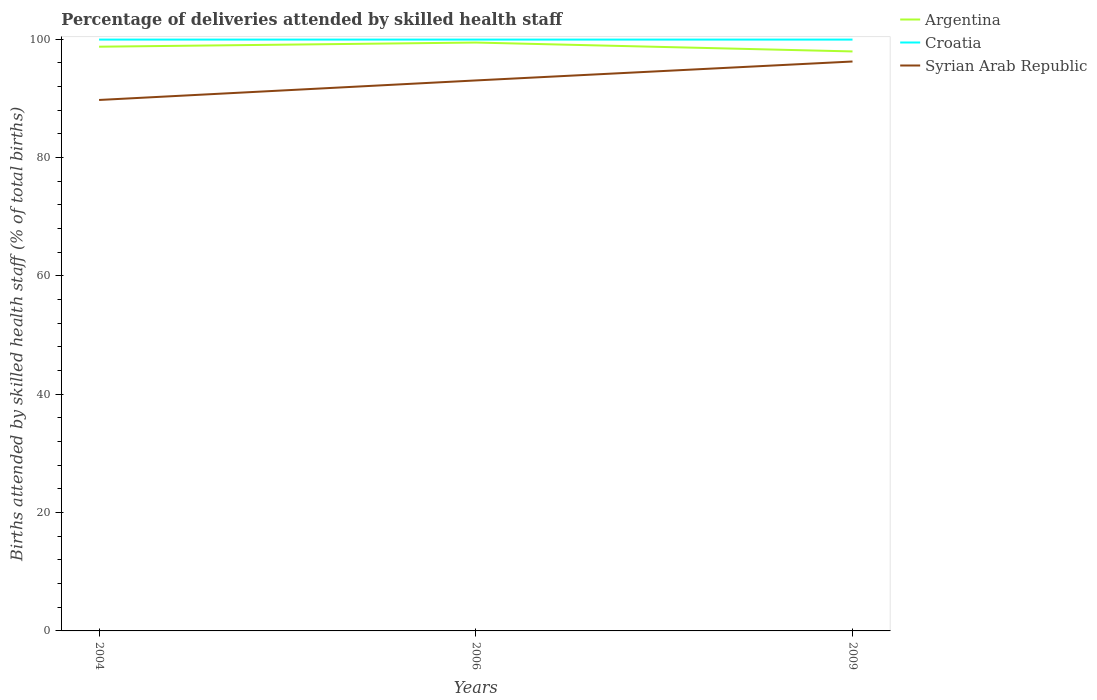How many different coloured lines are there?
Offer a very short reply. 3. Is the number of lines equal to the number of legend labels?
Make the answer very short. Yes. Across all years, what is the maximum percentage of births attended by skilled health staff in Syrian Arab Republic?
Make the answer very short. 89.7. In which year was the percentage of births attended by skilled health staff in Argentina maximum?
Your answer should be compact. 2009. What is the total percentage of births attended by skilled health staff in Argentina in the graph?
Offer a very short reply. -0.7. What is the difference between the highest and the lowest percentage of births attended by skilled health staff in Argentina?
Ensure brevity in your answer.  2. Is the percentage of births attended by skilled health staff in Croatia strictly greater than the percentage of births attended by skilled health staff in Argentina over the years?
Offer a terse response. No. How many lines are there?
Your answer should be very brief. 3. How many years are there in the graph?
Keep it short and to the point. 3. What is the difference between two consecutive major ticks on the Y-axis?
Your answer should be compact. 20. Are the values on the major ticks of Y-axis written in scientific E-notation?
Your response must be concise. No. Does the graph contain any zero values?
Keep it short and to the point. No. Where does the legend appear in the graph?
Ensure brevity in your answer.  Top right. What is the title of the graph?
Ensure brevity in your answer.  Percentage of deliveries attended by skilled health staff. Does "Middle East & North Africa (all income levels)" appear as one of the legend labels in the graph?
Keep it short and to the point. No. What is the label or title of the Y-axis?
Your answer should be compact. Births attended by skilled health staff (% of total births). What is the Births attended by skilled health staff (% of total births) of Argentina in 2004?
Provide a succinct answer. 98.7. What is the Births attended by skilled health staff (% of total births) of Croatia in 2004?
Make the answer very short. 99.9. What is the Births attended by skilled health staff (% of total births) of Syrian Arab Republic in 2004?
Provide a succinct answer. 89.7. What is the Births attended by skilled health staff (% of total births) of Argentina in 2006?
Keep it short and to the point. 99.4. What is the Births attended by skilled health staff (% of total births) in Croatia in 2006?
Provide a succinct answer. 99.9. What is the Births attended by skilled health staff (% of total births) in Syrian Arab Republic in 2006?
Your answer should be compact. 93. What is the Births attended by skilled health staff (% of total births) of Argentina in 2009?
Provide a succinct answer. 97.9. What is the Births attended by skilled health staff (% of total births) in Croatia in 2009?
Provide a short and direct response. 99.9. What is the Births attended by skilled health staff (% of total births) of Syrian Arab Republic in 2009?
Your response must be concise. 96.2. Across all years, what is the maximum Births attended by skilled health staff (% of total births) of Argentina?
Ensure brevity in your answer.  99.4. Across all years, what is the maximum Births attended by skilled health staff (% of total births) in Croatia?
Keep it short and to the point. 99.9. Across all years, what is the maximum Births attended by skilled health staff (% of total births) in Syrian Arab Republic?
Your answer should be compact. 96.2. Across all years, what is the minimum Births attended by skilled health staff (% of total births) of Argentina?
Provide a succinct answer. 97.9. Across all years, what is the minimum Births attended by skilled health staff (% of total births) in Croatia?
Provide a succinct answer. 99.9. Across all years, what is the minimum Births attended by skilled health staff (% of total births) of Syrian Arab Republic?
Give a very brief answer. 89.7. What is the total Births attended by skilled health staff (% of total births) in Argentina in the graph?
Ensure brevity in your answer.  296. What is the total Births attended by skilled health staff (% of total births) in Croatia in the graph?
Offer a terse response. 299.7. What is the total Births attended by skilled health staff (% of total births) in Syrian Arab Republic in the graph?
Your answer should be compact. 278.9. What is the difference between the Births attended by skilled health staff (% of total births) in Argentina in 2004 and that in 2006?
Offer a terse response. -0.7. What is the difference between the Births attended by skilled health staff (% of total births) of Croatia in 2004 and that in 2006?
Your response must be concise. 0. What is the difference between the Births attended by skilled health staff (% of total births) in Syrian Arab Republic in 2004 and that in 2006?
Give a very brief answer. -3.3. What is the difference between the Births attended by skilled health staff (% of total births) of Croatia in 2004 and that in 2009?
Your answer should be very brief. 0. What is the difference between the Births attended by skilled health staff (% of total births) in Syrian Arab Republic in 2004 and that in 2009?
Offer a terse response. -6.5. What is the difference between the Births attended by skilled health staff (% of total births) of Syrian Arab Republic in 2006 and that in 2009?
Provide a short and direct response. -3.2. What is the difference between the Births attended by skilled health staff (% of total births) of Argentina in 2004 and the Births attended by skilled health staff (% of total births) of Croatia in 2006?
Offer a very short reply. -1.2. What is the difference between the Births attended by skilled health staff (% of total births) in Croatia in 2004 and the Births attended by skilled health staff (% of total births) in Syrian Arab Republic in 2006?
Provide a succinct answer. 6.9. What is the difference between the Births attended by skilled health staff (% of total births) in Argentina in 2004 and the Births attended by skilled health staff (% of total births) in Croatia in 2009?
Offer a terse response. -1.2. What is the difference between the Births attended by skilled health staff (% of total births) in Croatia in 2004 and the Births attended by skilled health staff (% of total births) in Syrian Arab Republic in 2009?
Your answer should be compact. 3.7. What is the difference between the Births attended by skilled health staff (% of total births) of Croatia in 2006 and the Births attended by skilled health staff (% of total births) of Syrian Arab Republic in 2009?
Give a very brief answer. 3.7. What is the average Births attended by skilled health staff (% of total births) in Argentina per year?
Ensure brevity in your answer.  98.67. What is the average Births attended by skilled health staff (% of total births) of Croatia per year?
Make the answer very short. 99.9. What is the average Births attended by skilled health staff (% of total births) of Syrian Arab Republic per year?
Ensure brevity in your answer.  92.97. In the year 2004, what is the difference between the Births attended by skilled health staff (% of total births) in Croatia and Births attended by skilled health staff (% of total births) in Syrian Arab Republic?
Keep it short and to the point. 10.2. In the year 2006, what is the difference between the Births attended by skilled health staff (% of total births) of Argentina and Births attended by skilled health staff (% of total births) of Croatia?
Ensure brevity in your answer.  -0.5. In the year 2006, what is the difference between the Births attended by skilled health staff (% of total births) in Argentina and Births attended by skilled health staff (% of total births) in Syrian Arab Republic?
Make the answer very short. 6.4. In the year 2006, what is the difference between the Births attended by skilled health staff (% of total births) in Croatia and Births attended by skilled health staff (% of total births) in Syrian Arab Republic?
Give a very brief answer. 6.9. In the year 2009, what is the difference between the Births attended by skilled health staff (% of total births) in Argentina and Births attended by skilled health staff (% of total births) in Croatia?
Offer a terse response. -2. What is the ratio of the Births attended by skilled health staff (% of total births) of Syrian Arab Republic in 2004 to that in 2006?
Your answer should be very brief. 0.96. What is the ratio of the Births attended by skilled health staff (% of total births) of Argentina in 2004 to that in 2009?
Give a very brief answer. 1.01. What is the ratio of the Births attended by skilled health staff (% of total births) in Croatia in 2004 to that in 2009?
Offer a terse response. 1. What is the ratio of the Births attended by skilled health staff (% of total births) in Syrian Arab Republic in 2004 to that in 2009?
Provide a succinct answer. 0.93. What is the ratio of the Births attended by skilled health staff (% of total births) of Argentina in 2006 to that in 2009?
Provide a short and direct response. 1.02. What is the ratio of the Births attended by skilled health staff (% of total births) of Syrian Arab Republic in 2006 to that in 2009?
Your answer should be very brief. 0.97. What is the difference between the highest and the second highest Births attended by skilled health staff (% of total births) of Argentina?
Offer a terse response. 0.7. What is the difference between the highest and the second highest Births attended by skilled health staff (% of total births) in Croatia?
Offer a terse response. 0. What is the difference between the highest and the second highest Births attended by skilled health staff (% of total births) of Syrian Arab Republic?
Make the answer very short. 3.2. What is the difference between the highest and the lowest Births attended by skilled health staff (% of total births) in Croatia?
Provide a short and direct response. 0. What is the difference between the highest and the lowest Births attended by skilled health staff (% of total births) of Syrian Arab Republic?
Keep it short and to the point. 6.5. 